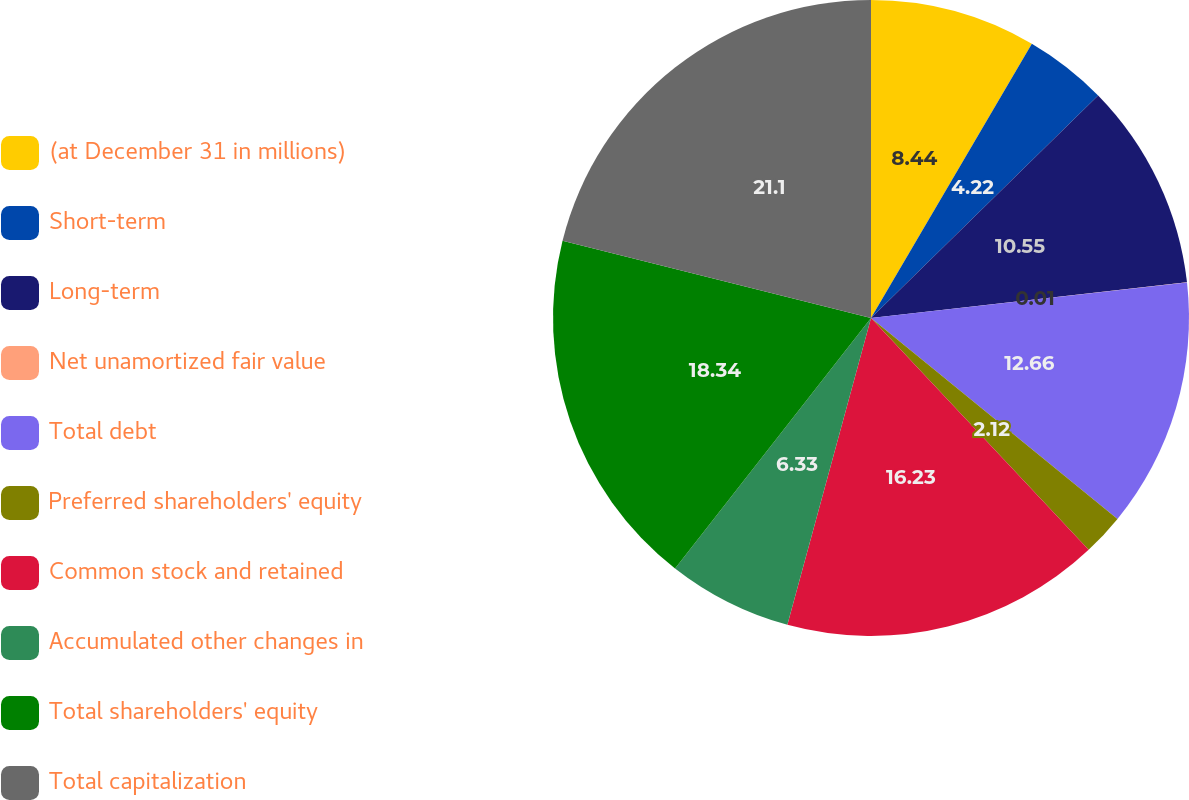<chart> <loc_0><loc_0><loc_500><loc_500><pie_chart><fcel>(at December 31 in millions)<fcel>Short-term<fcel>Long-term<fcel>Net unamortized fair value<fcel>Total debt<fcel>Preferred shareholders' equity<fcel>Common stock and retained<fcel>Accumulated other changes in<fcel>Total shareholders' equity<fcel>Total capitalization<nl><fcel>8.44%<fcel>4.22%<fcel>10.55%<fcel>0.01%<fcel>12.66%<fcel>2.12%<fcel>16.23%<fcel>6.33%<fcel>18.34%<fcel>21.09%<nl></chart> 